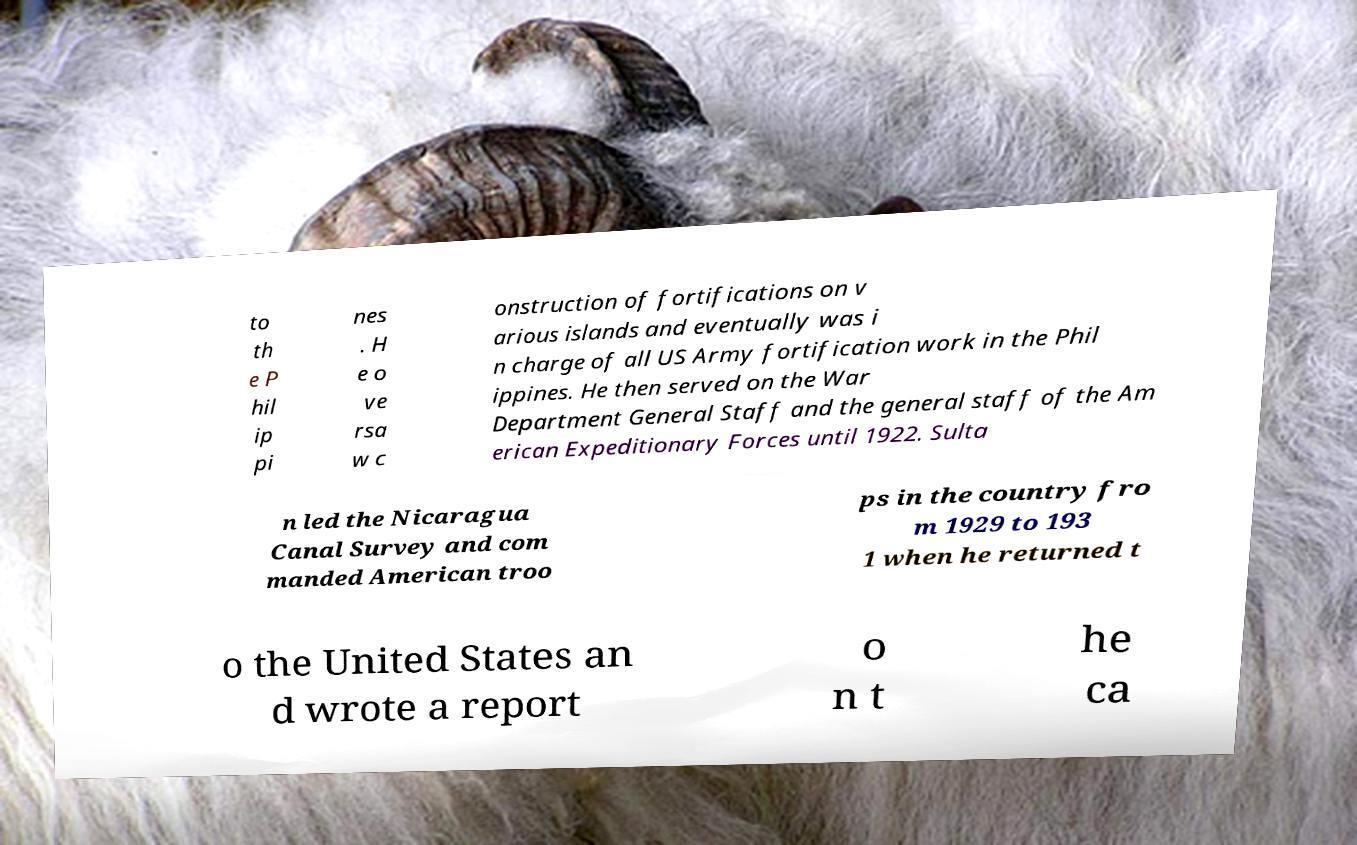Could you extract and type out the text from this image? to th e P hil ip pi nes . H e o ve rsa w c onstruction of fortifications on v arious islands and eventually was i n charge of all US Army fortification work in the Phil ippines. He then served on the War Department General Staff and the general staff of the Am erican Expeditionary Forces until 1922. Sulta n led the Nicaragua Canal Survey and com manded American troo ps in the country fro m 1929 to 193 1 when he returned t o the United States an d wrote a report o n t he ca 